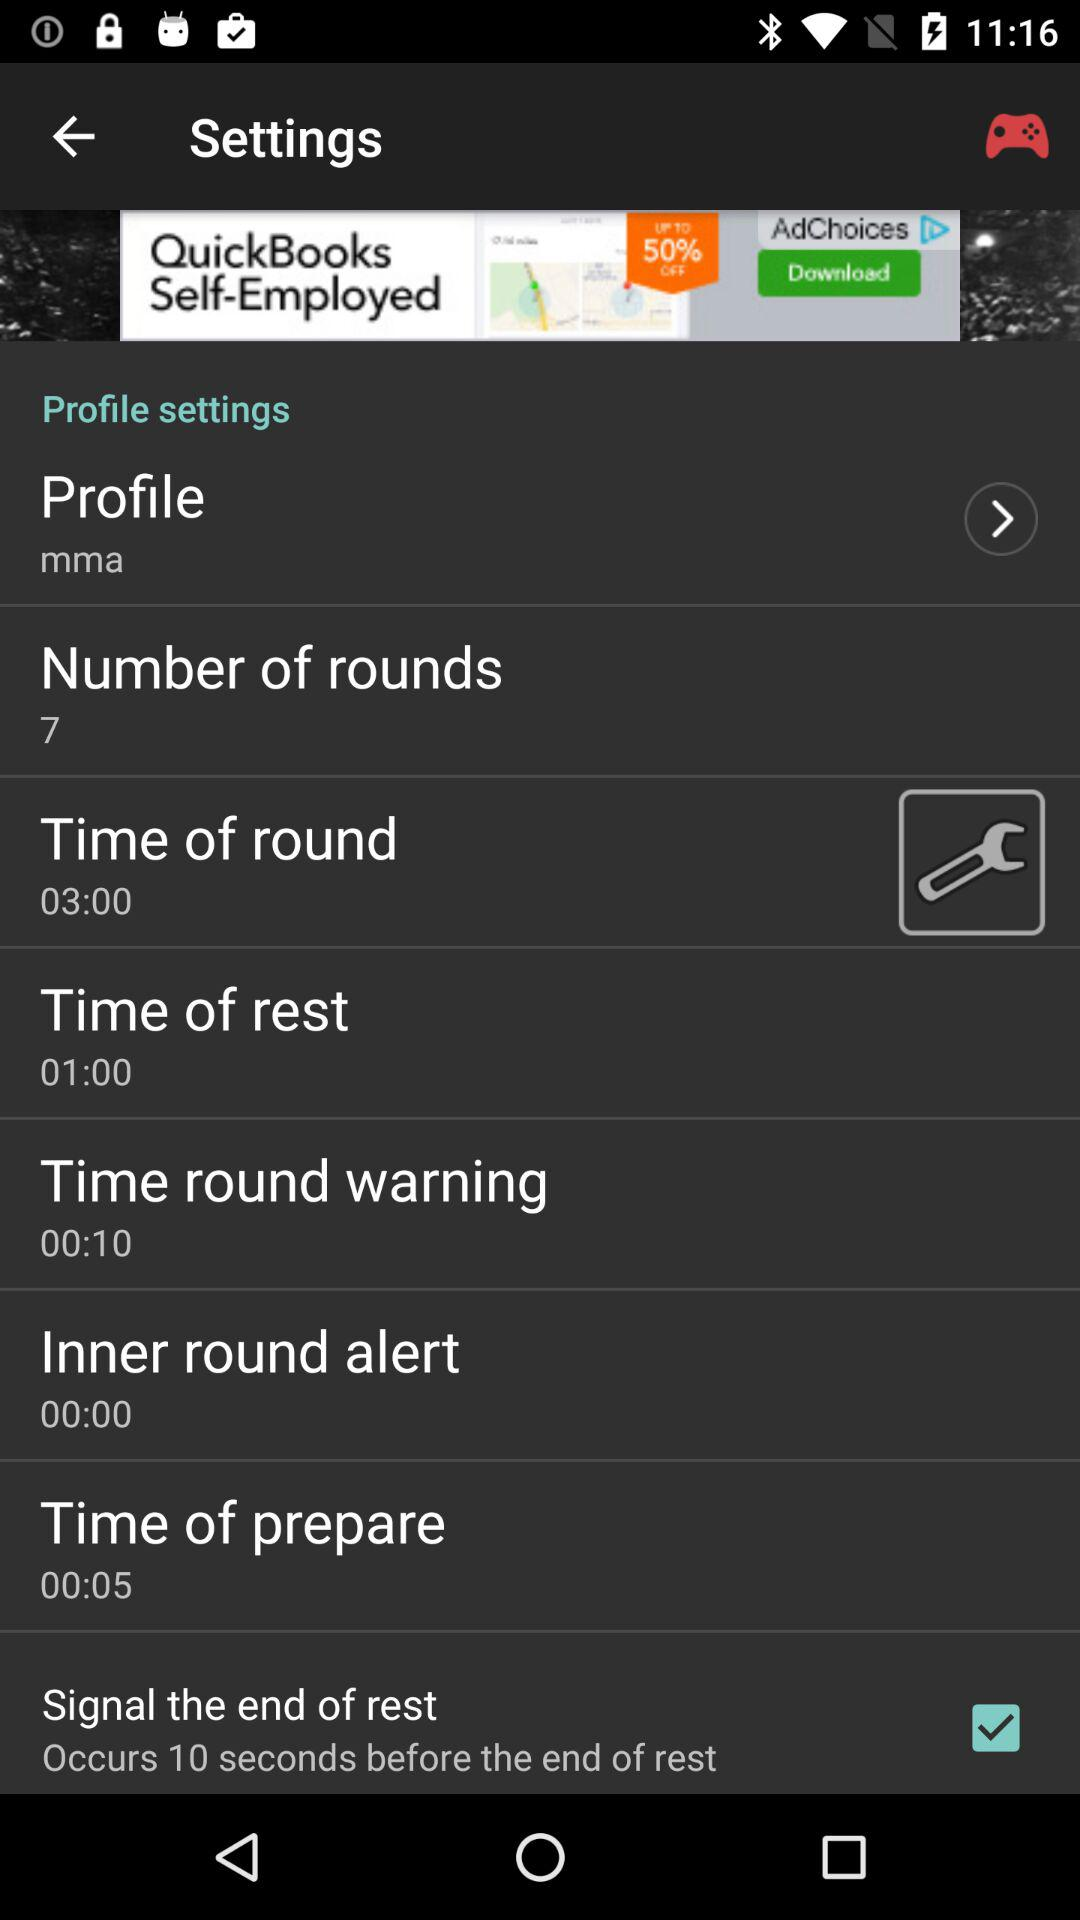What is the number of rounds? There are 7 rounds. 